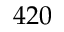Convert formula to latex. <formula><loc_0><loc_0><loc_500><loc_500>4 2 0</formula> 